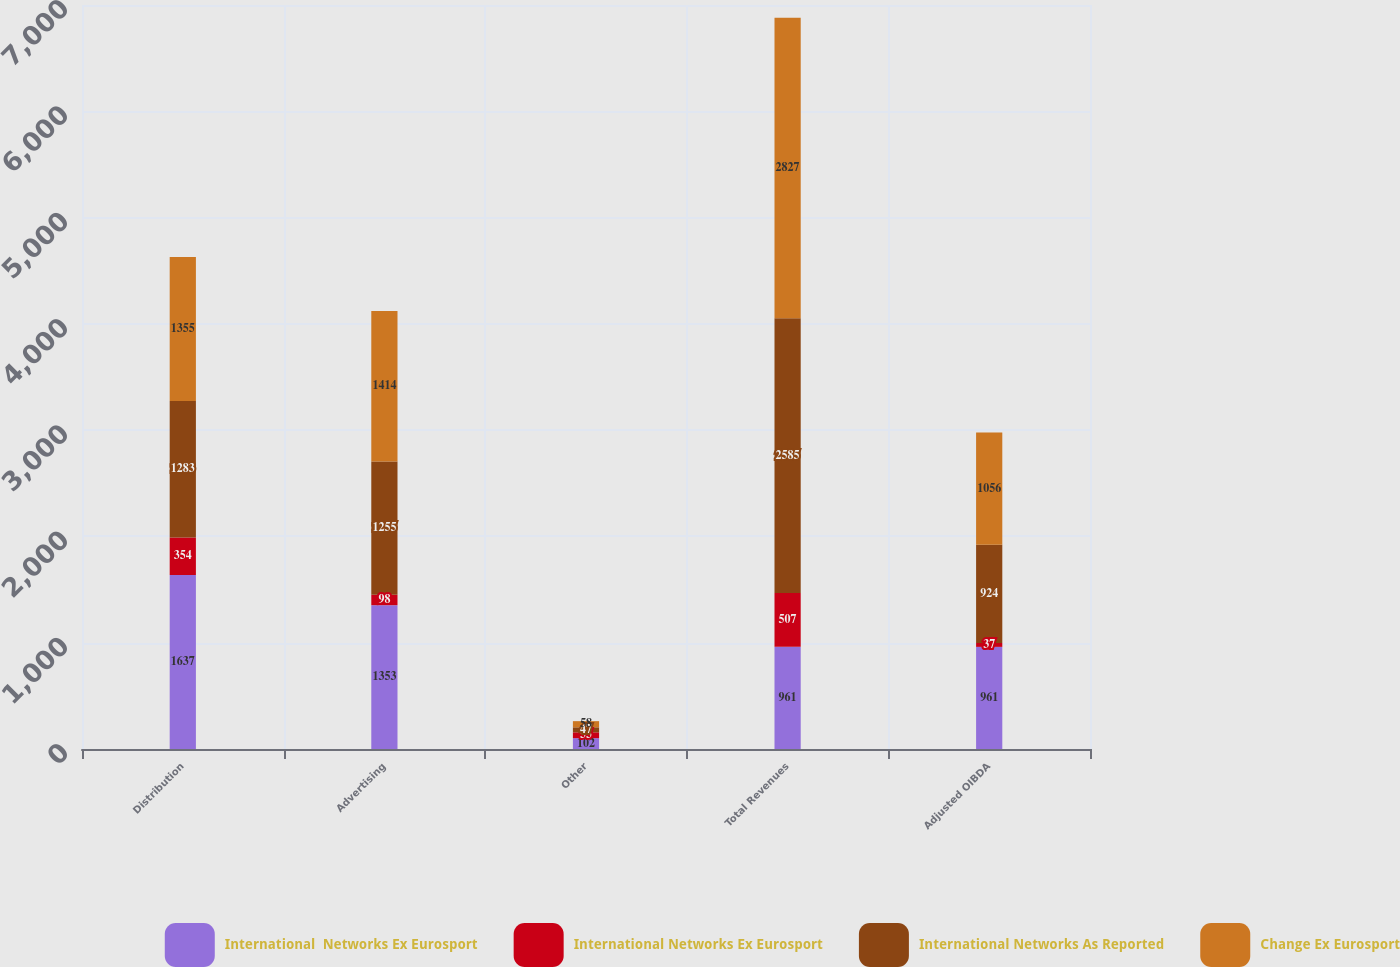<chart> <loc_0><loc_0><loc_500><loc_500><stacked_bar_chart><ecel><fcel>Distribution<fcel>Advertising<fcel>Other<fcel>Total Revenues<fcel>Adjusted OIBDA<nl><fcel>International  Networks Ex Eurosport<fcel>1637<fcel>1353<fcel>102<fcel>961<fcel>961<nl><fcel>International Networks Ex Eurosport<fcel>354<fcel>98<fcel>55<fcel>507<fcel>37<nl><fcel>International Networks As Reported<fcel>1283<fcel>1255<fcel>47<fcel>2585<fcel>924<nl><fcel>Change Ex Eurosport<fcel>1355<fcel>1414<fcel>58<fcel>2827<fcel>1056<nl></chart> 